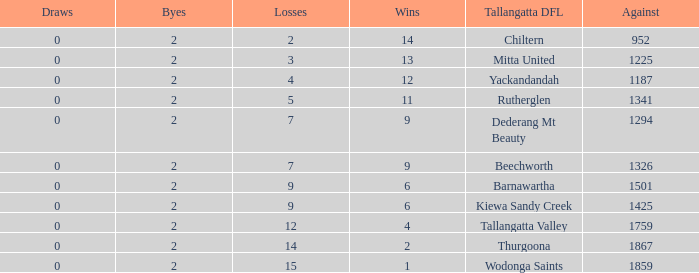What are the draws when wins are fwewer than 9 and byes fewer than 2? 0.0. 